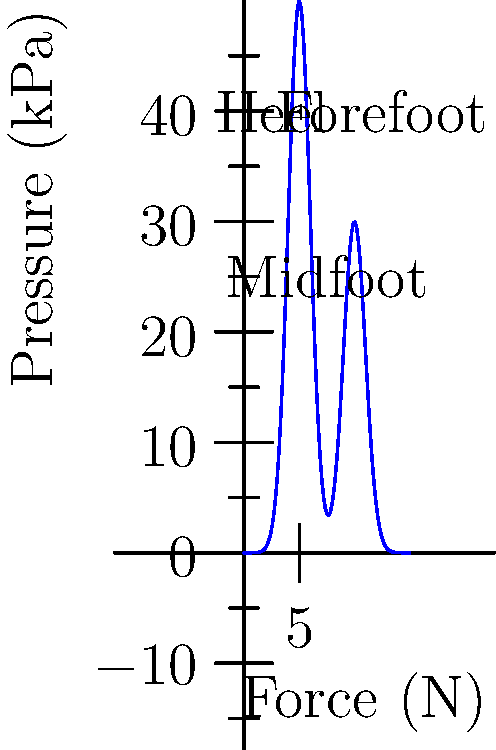As a manufacturer of high-quality athletic shoes, you're designing a specialized insole for runners. The graph shows the pressure distribution along the length of the foot during a typical running stride. What is the approximate ratio of peak pressure in the heel region to the peak pressure in the forefoot region? To solve this problem, we need to follow these steps:

1. Identify the peak pressures in the heel and forefoot regions:
   - The heel region is around 0-5 cm on the x-axis.
   - The forefoot region is around 10-15 cm on the x-axis.

2. Estimate the peak pressures:
   - Heel peak pressure: approximately 55 kPa
   - Forefoot peak pressure: approximately 50 kPa

3. Calculate the ratio:
   $$ \text{Ratio} = \frac{\text{Heel peak pressure}}{\text{Forefoot peak pressure}} = \frac{55 \text{ kPa}}{50 \text{ kPa}} \approx 1.1 $$

This ratio indicates that the peak pressure in the heel is slightly higher than in the forefoot, which is typical for many runners. As a manufacturer, this information can guide the design of insoles with appropriate cushioning and support in these high-pressure areas.
Answer: 1.1:1 